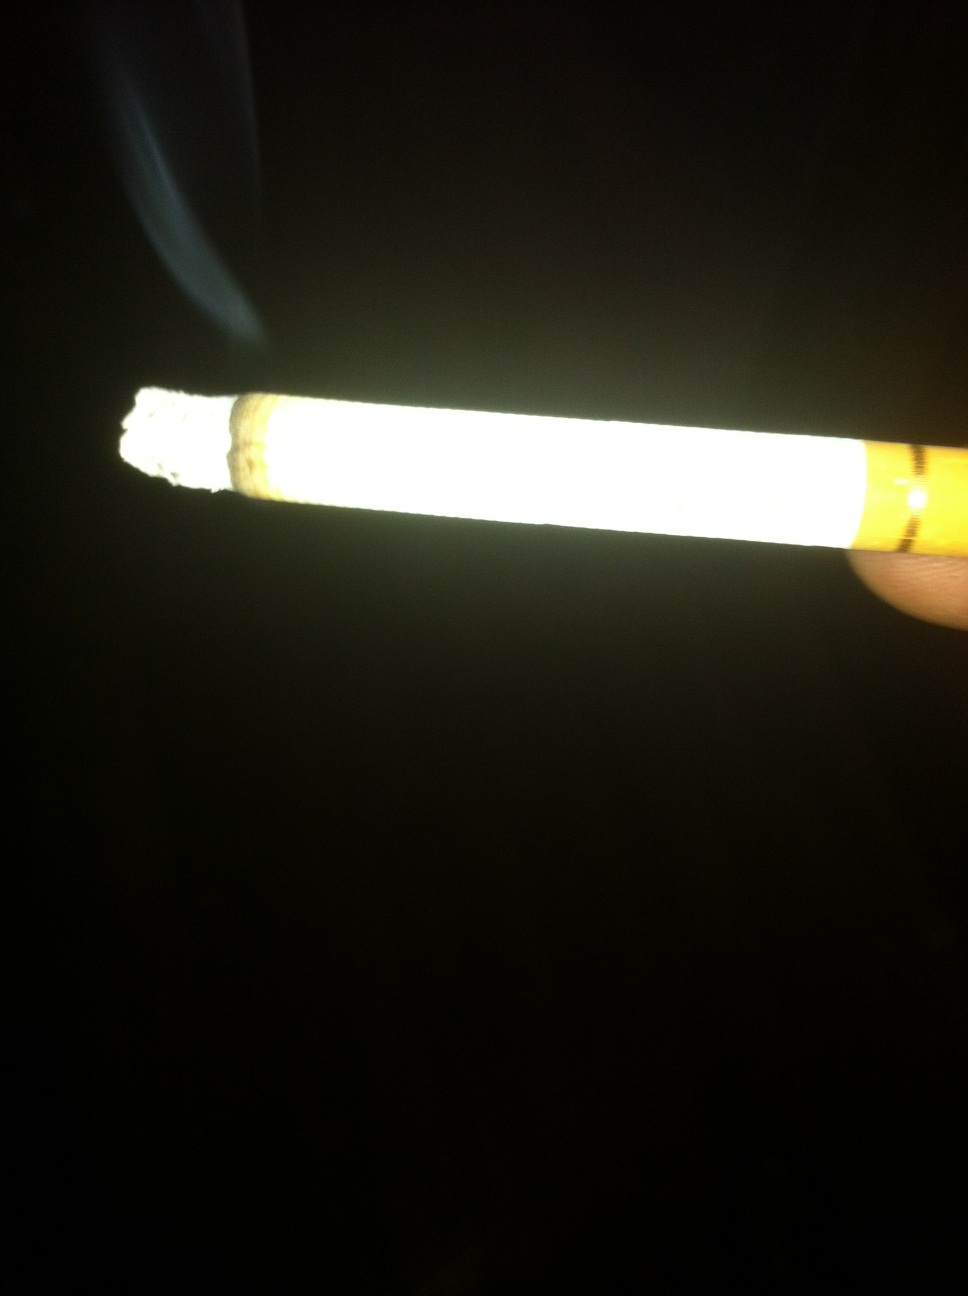Can you tell me more about the health implications of what's shown in the image? Certainly, the image displays a cigarette, which when used, is known to pose serious health risks, including lung cancer, heart disease, stroke, and chronic obstructive pulmonary disease among others. 